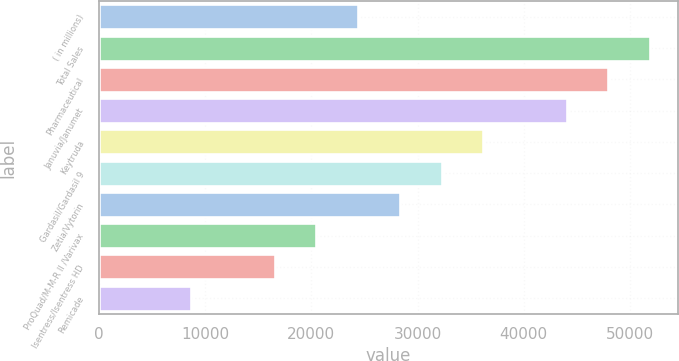Convert chart. <chart><loc_0><loc_0><loc_500><loc_500><bar_chart><fcel>( in millions)<fcel>Total Sales<fcel>Pharmaceutical<fcel>Januvia/Janumet<fcel>Keytruda<fcel>Gardasil/Gardasil 9<fcel>Zetia/Vytorin<fcel>ProQuad/M-M-R II /Varivax<fcel>Isentress/Isentress HD<fcel>Remicade<nl><fcel>24400.8<fcel>51912.9<fcel>47982.6<fcel>44052.3<fcel>36191.7<fcel>32261.4<fcel>28331.1<fcel>20470.5<fcel>16540.2<fcel>8679.6<nl></chart> 